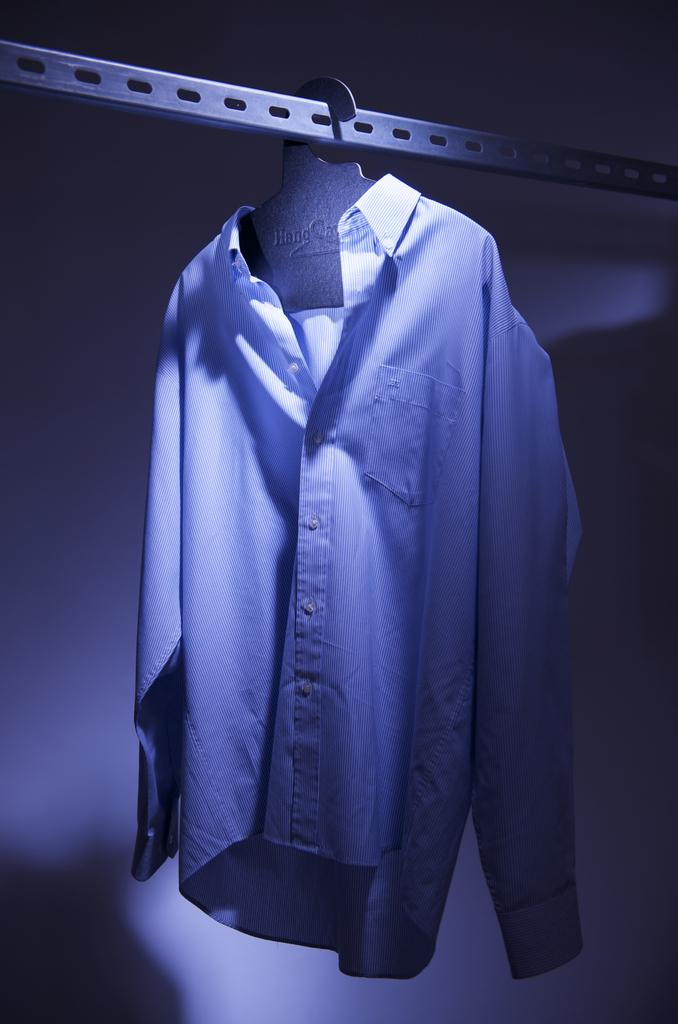What is hanging from the metal rod in the image? There is a hanger hanging from a metal rod in the image. What is on the hanger? There is a shirt on the hanger. What can be seen in the background of the image? There is a wall in the background of the image. What type of wool is used to make the vase in the image? There is no vase present in the image; it only features a hanger with a shirt and a wall in the background. 